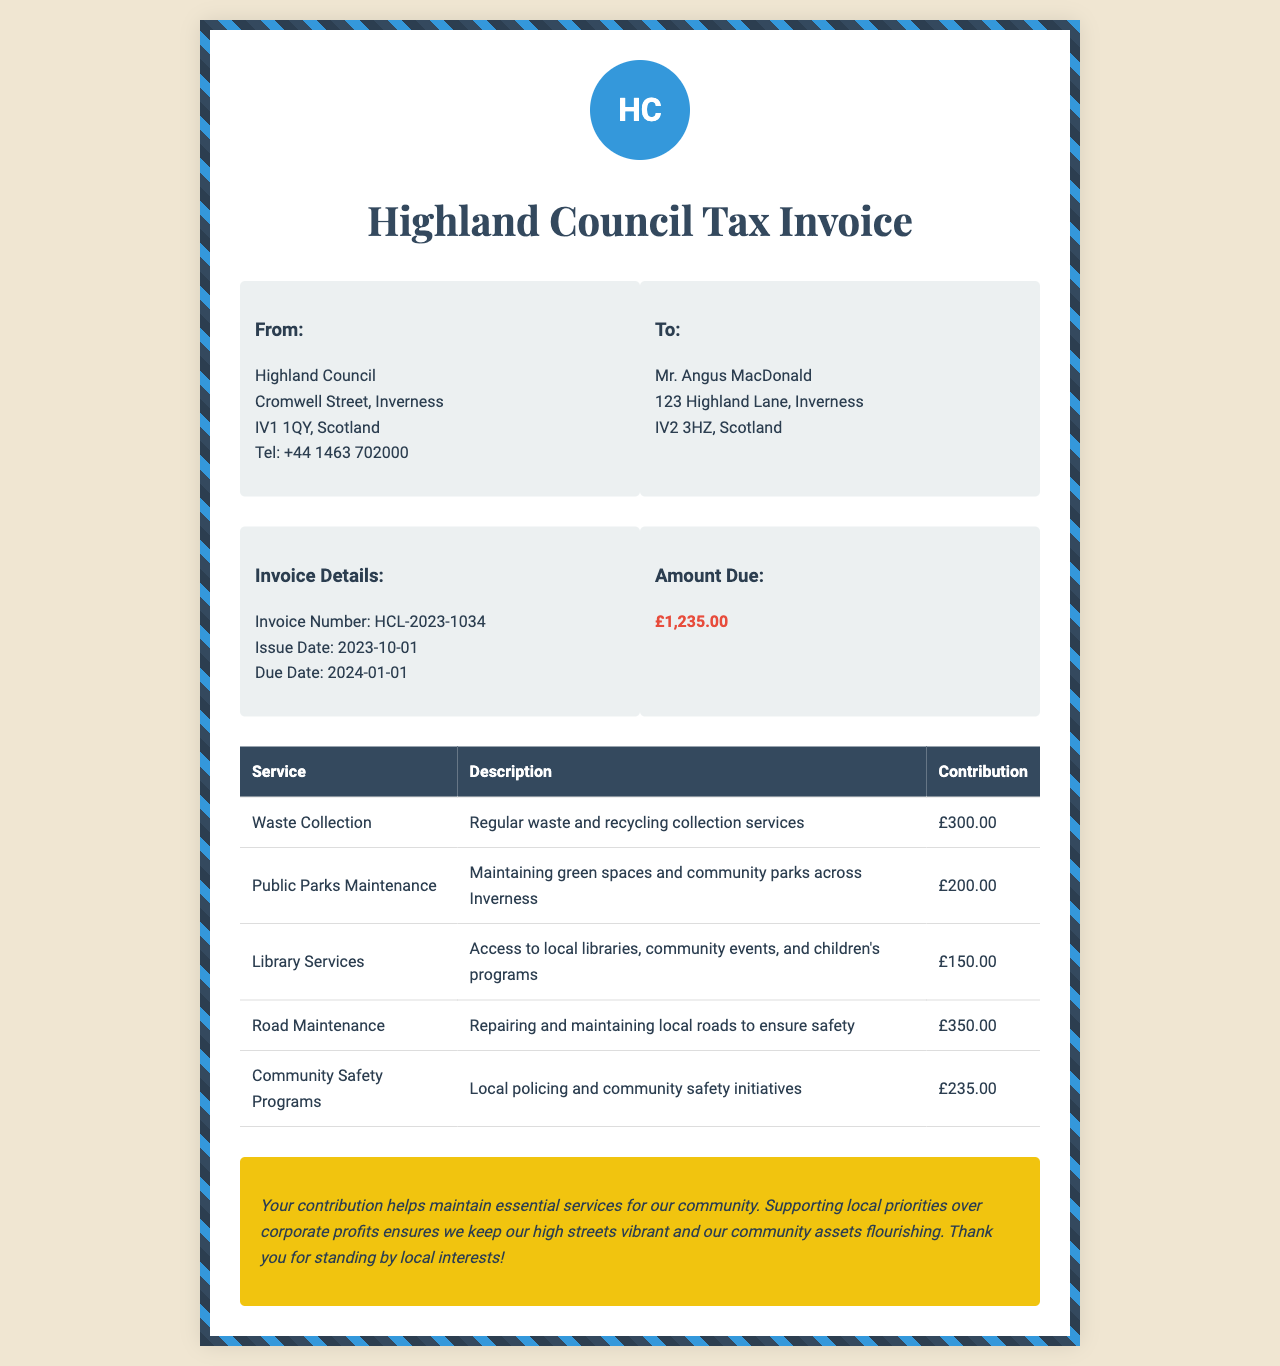What is the invoice number? The invoice number is listed under the invoice details section.
Answer: HCL-2023-1034 When is the due date for this invoice? The due date is specified in the invoice details.
Answer: 2024-01-01 How much is the amount due? The amount due is presented in the "Amount Due" section.
Answer: £1,235.00 What service provides access to local libraries? The service related to local libraries can be found in the services table.
Answer: Library Services How much is allocated to Road Maintenance? The amount allocated to Road Maintenance can be summed from the services listed.
Answer: £350.00 What is the total contribution for Waste Collection? The total contribution for Waste Collection is directly stated in the services table.
Answer: £300.00 Which service includes maintaining green spaces? The service responsible for maintaining green spaces is detailed in the services table.
Answer: Public Parks Maintenance What is noted about supporting local interests? The note emphasizes the importance of local contributions over corporate profits.
Answer: Thank you for standing by local interests! 